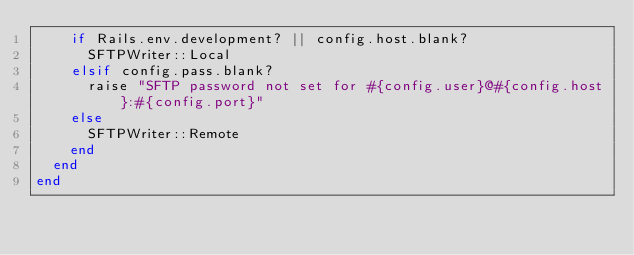<code> <loc_0><loc_0><loc_500><loc_500><_Ruby_>    if Rails.env.development? || config.host.blank?
      SFTPWriter::Local
    elsif config.pass.blank?
      raise "SFTP password not set for #{config.user}@#{config.host}:#{config.port}"
    else
      SFTPWriter::Remote
    end
  end
end
</code> 